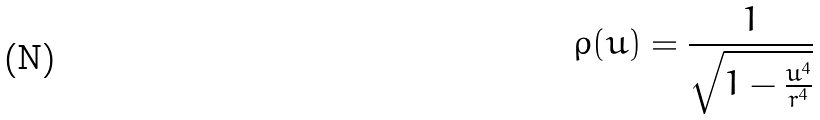Convert formula to latex. <formula><loc_0><loc_0><loc_500><loc_500>\rho ( u ) = \frac { 1 } { \sqrt { 1 - \frac { u ^ { 4 } } { r ^ { 4 } } } }</formula> 